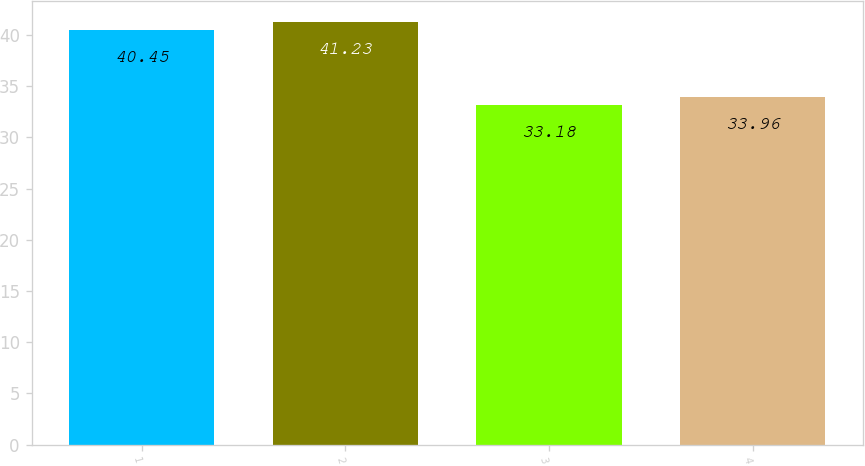Convert chart to OTSL. <chart><loc_0><loc_0><loc_500><loc_500><bar_chart><fcel>1<fcel>2<fcel>3<fcel>4<nl><fcel>40.45<fcel>41.23<fcel>33.18<fcel>33.96<nl></chart> 